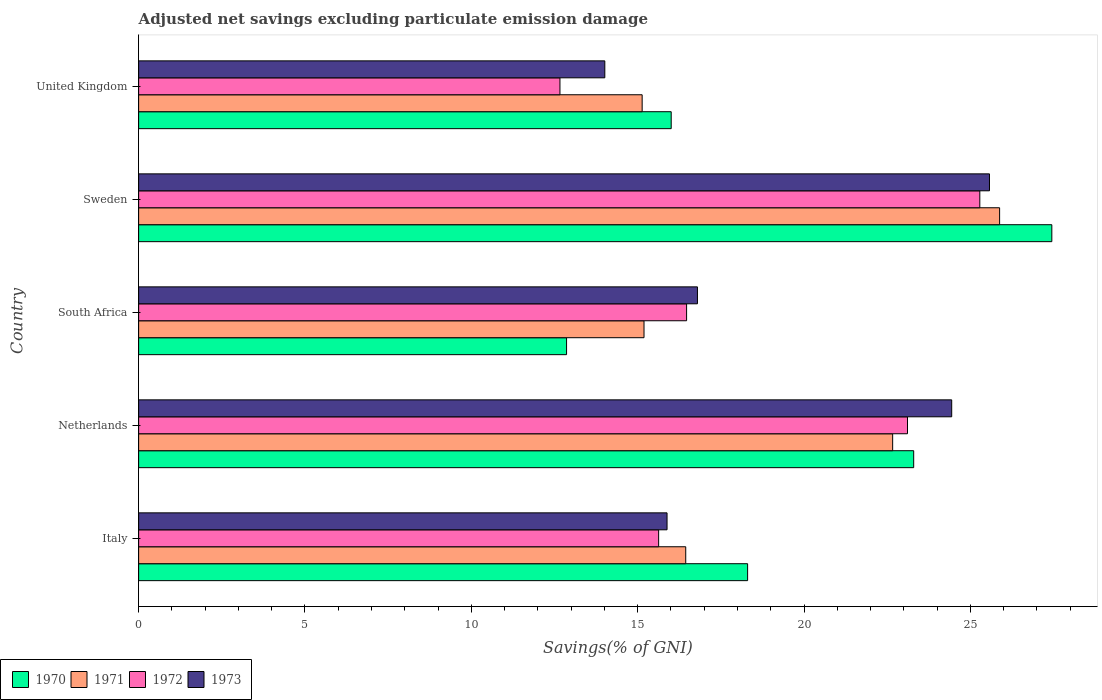How many groups of bars are there?
Give a very brief answer. 5. Are the number of bars per tick equal to the number of legend labels?
Ensure brevity in your answer.  Yes. Are the number of bars on each tick of the Y-axis equal?
Ensure brevity in your answer.  Yes. What is the label of the 3rd group of bars from the top?
Your answer should be compact. South Africa. What is the adjusted net savings in 1972 in South Africa?
Provide a short and direct response. 16.47. Across all countries, what is the maximum adjusted net savings in 1972?
Give a very brief answer. 25.28. Across all countries, what is the minimum adjusted net savings in 1972?
Give a very brief answer. 12.66. In which country was the adjusted net savings in 1972 maximum?
Offer a terse response. Sweden. What is the total adjusted net savings in 1973 in the graph?
Your answer should be compact. 96.7. What is the difference between the adjusted net savings in 1971 in South Africa and that in United Kingdom?
Your answer should be very brief. 0.06. What is the difference between the adjusted net savings in 1970 in Italy and the adjusted net savings in 1973 in South Africa?
Offer a terse response. 1.51. What is the average adjusted net savings in 1973 per country?
Offer a terse response. 19.34. What is the difference between the adjusted net savings in 1972 and adjusted net savings in 1973 in South Africa?
Offer a very short reply. -0.33. In how many countries, is the adjusted net savings in 1972 greater than 14 %?
Keep it short and to the point. 4. What is the ratio of the adjusted net savings in 1971 in Italy to that in South Africa?
Provide a short and direct response. 1.08. What is the difference between the highest and the second highest adjusted net savings in 1971?
Your response must be concise. 3.21. What is the difference between the highest and the lowest adjusted net savings in 1973?
Offer a very short reply. 11.56. What does the 3rd bar from the top in United Kingdom represents?
Provide a short and direct response. 1971. Is it the case that in every country, the sum of the adjusted net savings in 1973 and adjusted net savings in 1971 is greater than the adjusted net savings in 1972?
Provide a succinct answer. Yes. How many bars are there?
Offer a very short reply. 20. Are all the bars in the graph horizontal?
Provide a succinct answer. Yes. Are the values on the major ticks of X-axis written in scientific E-notation?
Give a very brief answer. No. Does the graph contain grids?
Keep it short and to the point. No. Where does the legend appear in the graph?
Make the answer very short. Bottom left. How are the legend labels stacked?
Provide a short and direct response. Horizontal. What is the title of the graph?
Make the answer very short. Adjusted net savings excluding particulate emission damage. What is the label or title of the X-axis?
Offer a terse response. Savings(% of GNI). What is the label or title of the Y-axis?
Offer a very short reply. Country. What is the Savings(% of GNI) of 1970 in Italy?
Make the answer very short. 18.3. What is the Savings(% of GNI) in 1971 in Italy?
Your answer should be compact. 16.44. What is the Savings(% of GNI) in 1972 in Italy?
Offer a very short reply. 15.63. What is the Savings(% of GNI) of 1973 in Italy?
Provide a succinct answer. 15.88. What is the Savings(% of GNI) of 1970 in Netherlands?
Provide a short and direct response. 23.3. What is the Savings(% of GNI) in 1971 in Netherlands?
Your response must be concise. 22.66. What is the Savings(% of GNI) in 1972 in Netherlands?
Your answer should be very brief. 23.11. What is the Savings(% of GNI) in 1973 in Netherlands?
Offer a very short reply. 24.44. What is the Savings(% of GNI) in 1970 in South Africa?
Make the answer very short. 12.86. What is the Savings(% of GNI) in 1971 in South Africa?
Make the answer very short. 15.19. What is the Savings(% of GNI) of 1972 in South Africa?
Your response must be concise. 16.47. What is the Savings(% of GNI) of 1973 in South Africa?
Your answer should be very brief. 16.8. What is the Savings(% of GNI) in 1970 in Sweden?
Your answer should be compact. 27.45. What is the Savings(% of GNI) of 1971 in Sweden?
Provide a short and direct response. 25.88. What is the Savings(% of GNI) in 1972 in Sweden?
Offer a very short reply. 25.28. What is the Savings(% of GNI) of 1973 in Sweden?
Ensure brevity in your answer.  25.57. What is the Savings(% of GNI) in 1970 in United Kingdom?
Your answer should be very brief. 16.01. What is the Savings(% of GNI) in 1971 in United Kingdom?
Provide a short and direct response. 15.13. What is the Savings(% of GNI) in 1972 in United Kingdom?
Your answer should be compact. 12.66. What is the Savings(% of GNI) of 1973 in United Kingdom?
Your answer should be very brief. 14.01. Across all countries, what is the maximum Savings(% of GNI) in 1970?
Make the answer very short. 27.45. Across all countries, what is the maximum Savings(% of GNI) in 1971?
Your response must be concise. 25.88. Across all countries, what is the maximum Savings(% of GNI) in 1972?
Provide a succinct answer. 25.28. Across all countries, what is the maximum Savings(% of GNI) of 1973?
Give a very brief answer. 25.57. Across all countries, what is the minimum Savings(% of GNI) in 1970?
Make the answer very short. 12.86. Across all countries, what is the minimum Savings(% of GNI) in 1971?
Offer a terse response. 15.13. Across all countries, what is the minimum Savings(% of GNI) in 1972?
Your answer should be compact. 12.66. Across all countries, what is the minimum Savings(% of GNI) in 1973?
Your response must be concise. 14.01. What is the total Savings(% of GNI) in 1970 in the graph?
Offer a very short reply. 97.92. What is the total Savings(% of GNI) of 1971 in the graph?
Ensure brevity in your answer.  95.31. What is the total Savings(% of GNI) in 1972 in the graph?
Give a very brief answer. 93.16. What is the total Savings(% of GNI) in 1973 in the graph?
Make the answer very short. 96.7. What is the difference between the Savings(% of GNI) of 1970 in Italy and that in Netherlands?
Offer a very short reply. -4.99. What is the difference between the Savings(% of GNI) in 1971 in Italy and that in Netherlands?
Give a very brief answer. -6.22. What is the difference between the Savings(% of GNI) of 1972 in Italy and that in Netherlands?
Give a very brief answer. -7.48. What is the difference between the Savings(% of GNI) in 1973 in Italy and that in Netherlands?
Provide a succinct answer. -8.56. What is the difference between the Savings(% of GNI) in 1970 in Italy and that in South Africa?
Provide a succinct answer. 5.44. What is the difference between the Savings(% of GNI) of 1971 in Italy and that in South Africa?
Your response must be concise. 1.25. What is the difference between the Savings(% of GNI) of 1972 in Italy and that in South Africa?
Ensure brevity in your answer.  -0.84. What is the difference between the Savings(% of GNI) in 1973 in Italy and that in South Africa?
Ensure brevity in your answer.  -0.91. What is the difference between the Savings(% of GNI) in 1970 in Italy and that in Sweden?
Offer a very short reply. -9.14. What is the difference between the Savings(% of GNI) in 1971 in Italy and that in Sweden?
Offer a very short reply. -9.43. What is the difference between the Savings(% of GNI) in 1972 in Italy and that in Sweden?
Your answer should be very brief. -9.65. What is the difference between the Savings(% of GNI) in 1973 in Italy and that in Sweden?
Provide a short and direct response. -9.69. What is the difference between the Savings(% of GNI) of 1970 in Italy and that in United Kingdom?
Your answer should be compact. 2.3. What is the difference between the Savings(% of GNI) in 1971 in Italy and that in United Kingdom?
Offer a very short reply. 1.31. What is the difference between the Savings(% of GNI) of 1972 in Italy and that in United Kingdom?
Provide a succinct answer. 2.97. What is the difference between the Savings(% of GNI) in 1973 in Italy and that in United Kingdom?
Your answer should be very brief. 1.87. What is the difference between the Savings(% of GNI) in 1970 in Netherlands and that in South Africa?
Give a very brief answer. 10.43. What is the difference between the Savings(% of GNI) in 1971 in Netherlands and that in South Africa?
Make the answer very short. 7.47. What is the difference between the Savings(% of GNI) of 1972 in Netherlands and that in South Africa?
Provide a short and direct response. 6.64. What is the difference between the Savings(% of GNI) of 1973 in Netherlands and that in South Africa?
Your response must be concise. 7.64. What is the difference between the Savings(% of GNI) of 1970 in Netherlands and that in Sweden?
Your response must be concise. -4.15. What is the difference between the Savings(% of GNI) in 1971 in Netherlands and that in Sweden?
Your answer should be compact. -3.21. What is the difference between the Savings(% of GNI) in 1972 in Netherlands and that in Sweden?
Keep it short and to the point. -2.17. What is the difference between the Savings(% of GNI) of 1973 in Netherlands and that in Sweden?
Your response must be concise. -1.14. What is the difference between the Savings(% of GNI) in 1970 in Netherlands and that in United Kingdom?
Your answer should be compact. 7.29. What is the difference between the Savings(% of GNI) in 1971 in Netherlands and that in United Kingdom?
Provide a short and direct response. 7.53. What is the difference between the Savings(% of GNI) of 1972 in Netherlands and that in United Kingdom?
Give a very brief answer. 10.45. What is the difference between the Savings(% of GNI) of 1973 in Netherlands and that in United Kingdom?
Provide a succinct answer. 10.43. What is the difference between the Savings(% of GNI) in 1970 in South Africa and that in Sweden?
Your answer should be compact. -14.59. What is the difference between the Savings(% of GNI) in 1971 in South Africa and that in Sweden?
Keep it short and to the point. -10.69. What is the difference between the Savings(% of GNI) of 1972 in South Africa and that in Sweden?
Give a very brief answer. -8.81. What is the difference between the Savings(% of GNI) of 1973 in South Africa and that in Sweden?
Give a very brief answer. -8.78. What is the difference between the Savings(% of GNI) in 1970 in South Africa and that in United Kingdom?
Offer a terse response. -3.15. What is the difference between the Savings(% of GNI) of 1971 in South Africa and that in United Kingdom?
Ensure brevity in your answer.  0.06. What is the difference between the Savings(% of GNI) in 1972 in South Africa and that in United Kingdom?
Keep it short and to the point. 3.81. What is the difference between the Savings(% of GNI) of 1973 in South Africa and that in United Kingdom?
Keep it short and to the point. 2.78. What is the difference between the Savings(% of GNI) of 1970 in Sweden and that in United Kingdom?
Your response must be concise. 11.44. What is the difference between the Savings(% of GNI) in 1971 in Sweden and that in United Kingdom?
Offer a very short reply. 10.74. What is the difference between the Savings(% of GNI) in 1972 in Sweden and that in United Kingdom?
Keep it short and to the point. 12.62. What is the difference between the Savings(% of GNI) in 1973 in Sweden and that in United Kingdom?
Keep it short and to the point. 11.56. What is the difference between the Savings(% of GNI) in 1970 in Italy and the Savings(% of GNI) in 1971 in Netherlands?
Your answer should be compact. -4.36. What is the difference between the Savings(% of GNI) in 1970 in Italy and the Savings(% of GNI) in 1972 in Netherlands?
Offer a terse response. -4.81. What is the difference between the Savings(% of GNI) of 1970 in Italy and the Savings(% of GNI) of 1973 in Netherlands?
Offer a very short reply. -6.13. What is the difference between the Savings(% of GNI) of 1971 in Italy and the Savings(% of GNI) of 1972 in Netherlands?
Give a very brief answer. -6.67. What is the difference between the Savings(% of GNI) in 1971 in Italy and the Savings(% of GNI) in 1973 in Netherlands?
Ensure brevity in your answer.  -7.99. What is the difference between the Savings(% of GNI) of 1972 in Italy and the Savings(% of GNI) of 1973 in Netherlands?
Ensure brevity in your answer.  -8.81. What is the difference between the Savings(% of GNI) in 1970 in Italy and the Savings(% of GNI) in 1971 in South Africa?
Your answer should be compact. 3.11. What is the difference between the Savings(% of GNI) in 1970 in Italy and the Savings(% of GNI) in 1972 in South Africa?
Offer a very short reply. 1.83. What is the difference between the Savings(% of GNI) of 1970 in Italy and the Savings(% of GNI) of 1973 in South Africa?
Your response must be concise. 1.51. What is the difference between the Savings(% of GNI) in 1971 in Italy and the Savings(% of GNI) in 1972 in South Africa?
Your answer should be compact. -0.03. What is the difference between the Savings(% of GNI) of 1971 in Italy and the Savings(% of GNI) of 1973 in South Africa?
Make the answer very short. -0.35. What is the difference between the Savings(% of GNI) in 1972 in Italy and the Savings(% of GNI) in 1973 in South Africa?
Make the answer very short. -1.17. What is the difference between the Savings(% of GNI) in 1970 in Italy and the Savings(% of GNI) in 1971 in Sweden?
Give a very brief answer. -7.57. What is the difference between the Savings(% of GNI) of 1970 in Italy and the Savings(% of GNI) of 1972 in Sweden?
Provide a succinct answer. -6.98. What is the difference between the Savings(% of GNI) of 1970 in Italy and the Savings(% of GNI) of 1973 in Sweden?
Offer a very short reply. -7.27. What is the difference between the Savings(% of GNI) in 1971 in Italy and the Savings(% of GNI) in 1972 in Sweden?
Your response must be concise. -8.84. What is the difference between the Savings(% of GNI) of 1971 in Italy and the Savings(% of GNI) of 1973 in Sweden?
Your answer should be compact. -9.13. What is the difference between the Savings(% of GNI) in 1972 in Italy and the Savings(% of GNI) in 1973 in Sweden?
Make the answer very short. -9.94. What is the difference between the Savings(% of GNI) in 1970 in Italy and the Savings(% of GNI) in 1971 in United Kingdom?
Ensure brevity in your answer.  3.17. What is the difference between the Savings(% of GNI) in 1970 in Italy and the Savings(% of GNI) in 1972 in United Kingdom?
Make the answer very short. 5.64. What is the difference between the Savings(% of GNI) of 1970 in Italy and the Savings(% of GNI) of 1973 in United Kingdom?
Make the answer very short. 4.29. What is the difference between the Savings(% of GNI) of 1971 in Italy and the Savings(% of GNI) of 1972 in United Kingdom?
Your answer should be very brief. 3.78. What is the difference between the Savings(% of GNI) in 1971 in Italy and the Savings(% of GNI) in 1973 in United Kingdom?
Make the answer very short. 2.43. What is the difference between the Savings(% of GNI) in 1972 in Italy and the Savings(% of GNI) in 1973 in United Kingdom?
Your answer should be very brief. 1.62. What is the difference between the Savings(% of GNI) of 1970 in Netherlands and the Savings(% of GNI) of 1971 in South Africa?
Offer a terse response. 8.11. What is the difference between the Savings(% of GNI) of 1970 in Netherlands and the Savings(% of GNI) of 1972 in South Africa?
Your answer should be compact. 6.83. What is the difference between the Savings(% of GNI) of 1970 in Netherlands and the Savings(% of GNI) of 1973 in South Africa?
Your response must be concise. 6.5. What is the difference between the Savings(% of GNI) of 1971 in Netherlands and the Savings(% of GNI) of 1972 in South Africa?
Keep it short and to the point. 6.19. What is the difference between the Savings(% of GNI) in 1971 in Netherlands and the Savings(% of GNI) in 1973 in South Africa?
Ensure brevity in your answer.  5.87. What is the difference between the Savings(% of GNI) in 1972 in Netherlands and the Savings(% of GNI) in 1973 in South Africa?
Your answer should be compact. 6.31. What is the difference between the Savings(% of GNI) of 1970 in Netherlands and the Savings(% of GNI) of 1971 in Sweden?
Ensure brevity in your answer.  -2.58. What is the difference between the Savings(% of GNI) in 1970 in Netherlands and the Savings(% of GNI) in 1972 in Sweden?
Your answer should be very brief. -1.99. What is the difference between the Savings(% of GNI) of 1970 in Netherlands and the Savings(% of GNI) of 1973 in Sweden?
Provide a succinct answer. -2.28. What is the difference between the Savings(% of GNI) of 1971 in Netherlands and the Savings(% of GNI) of 1972 in Sweden?
Ensure brevity in your answer.  -2.62. What is the difference between the Savings(% of GNI) of 1971 in Netherlands and the Savings(% of GNI) of 1973 in Sweden?
Provide a short and direct response. -2.91. What is the difference between the Savings(% of GNI) in 1972 in Netherlands and the Savings(% of GNI) in 1973 in Sweden?
Your answer should be compact. -2.46. What is the difference between the Savings(% of GNI) of 1970 in Netherlands and the Savings(% of GNI) of 1971 in United Kingdom?
Your answer should be very brief. 8.16. What is the difference between the Savings(% of GNI) in 1970 in Netherlands and the Savings(% of GNI) in 1972 in United Kingdom?
Your answer should be compact. 10.63. What is the difference between the Savings(% of GNI) in 1970 in Netherlands and the Savings(% of GNI) in 1973 in United Kingdom?
Give a very brief answer. 9.28. What is the difference between the Savings(% of GNI) of 1971 in Netherlands and the Savings(% of GNI) of 1972 in United Kingdom?
Your response must be concise. 10. What is the difference between the Savings(% of GNI) in 1971 in Netherlands and the Savings(% of GNI) in 1973 in United Kingdom?
Keep it short and to the point. 8.65. What is the difference between the Savings(% of GNI) in 1972 in Netherlands and the Savings(% of GNI) in 1973 in United Kingdom?
Your response must be concise. 9.1. What is the difference between the Savings(% of GNI) in 1970 in South Africa and the Savings(% of GNI) in 1971 in Sweden?
Provide a succinct answer. -13.02. What is the difference between the Savings(% of GNI) in 1970 in South Africa and the Savings(% of GNI) in 1972 in Sweden?
Your response must be concise. -12.42. What is the difference between the Savings(% of GNI) in 1970 in South Africa and the Savings(% of GNI) in 1973 in Sweden?
Provide a succinct answer. -12.71. What is the difference between the Savings(% of GNI) in 1971 in South Africa and the Savings(% of GNI) in 1972 in Sweden?
Keep it short and to the point. -10.09. What is the difference between the Savings(% of GNI) of 1971 in South Africa and the Savings(% of GNI) of 1973 in Sweden?
Offer a terse response. -10.38. What is the difference between the Savings(% of GNI) of 1972 in South Africa and the Savings(% of GNI) of 1973 in Sweden?
Make the answer very short. -9.1. What is the difference between the Savings(% of GNI) of 1970 in South Africa and the Savings(% of GNI) of 1971 in United Kingdom?
Your answer should be very brief. -2.27. What is the difference between the Savings(% of GNI) of 1970 in South Africa and the Savings(% of GNI) of 1972 in United Kingdom?
Provide a succinct answer. 0.2. What is the difference between the Savings(% of GNI) of 1970 in South Africa and the Savings(% of GNI) of 1973 in United Kingdom?
Your response must be concise. -1.15. What is the difference between the Savings(% of GNI) in 1971 in South Africa and the Savings(% of GNI) in 1972 in United Kingdom?
Offer a terse response. 2.53. What is the difference between the Savings(% of GNI) in 1971 in South Africa and the Savings(% of GNI) in 1973 in United Kingdom?
Ensure brevity in your answer.  1.18. What is the difference between the Savings(% of GNI) of 1972 in South Africa and the Savings(% of GNI) of 1973 in United Kingdom?
Ensure brevity in your answer.  2.46. What is the difference between the Savings(% of GNI) in 1970 in Sweden and the Savings(% of GNI) in 1971 in United Kingdom?
Keep it short and to the point. 12.31. What is the difference between the Savings(% of GNI) of 1970 in Sweden and the Savings(% of GNI) of 1972 in United Kingdom?
Offer a terse response. 14.78. What is the difference between the Savings(% of GNI) in 1970 in Sweden and the Savings(% of GNI) in 1973 in United Kingdom?
Your response must be concise. 13.44. What is the difference between the Savings(% of GNI) of 1971 in Sweden and the Savings(% of GNI) of 1972 in United Kingdom?
Ensure brevity in your answer.  13.21. What is the difference between the Savings(% of GNI) of 1971 in Sweden and the Savings(% of GNI) of 1973 in United Kingdom?
Give a very brief answer. 11.87. What is the difference between the Savings(% of GNI) in 1972 in Sweden and the Savings(% of GNI) in 1973 in United Kingdom?
Provide a succinct answer. 11.27. What is the average Savings(% of GNI) of 1970 per country?
Your response must be concise. 19.58. What is the average Savings(% of GNI) of 1971 per country?
Ensure brevity in your answer.  19.06. What is the average Savings(% of GNI) of 1972 per country?
Ensure brevity in your answer.  18.63. What is the average Savings(% of GNI) of 1973 per country?
Provide a succinct answer. 19.34. What is the difference between the Savings(% of GNI) in 1970 and Savings(% of GNI) in 1971 in Italy?
Your response must be concise. 1.86. What is the difference between the Savings(% of GNI) in 1970 and Savings(% of GNI) in 1972 in Italy?
Ensure brevity in your answer.  2.67. What is the difference between the Savings(% of GNI) of 1970 and Savings(% of GNI) of 1973 in Italy?
Your response must be concise. 2.42. What is the difference between the Savings(% of GNI) in 1971 and Savings(% of GNI) in 1972 in Italy?
Give a very brief answer. 0.81. What is the difference between the Savings(% of GNI) in 1971 and Savings(% of GNI) in 1973 in Italy?
Your answer should be very brief. 0.56. What is the difference between the Savings(% of GNI) in 1972 and Savings(% of GNI) in 1973 in Italy?
Make the answer very short. -0.25. What is the difference between the Savings(% of GNI) of 1970 and Savings(% of GNI) of 1971 in Netherlands?
Your response must be concise. 0.63. What is the difference between the Savings(% of GNI) of 1970 and Savings(% of GNI) of 1972 in Netherlands?
Make the answer very short. 0.19. What is the difference between the Savings(% of GNI) of 1970 and Savings(% of GNI) of 1973 in Netherlands?
Give a very brief answer. -1.14. What is the difference between the Savings(% of GNI) in 1971 and Savings(% of GNI) in 1972 in Netherlands?
Offer a terse response. -0.45. What is the difference between the Savings(% of GNI) in 1971 and Savings(% of GNI) in 1973 in Netherlands?
Your response must be concise. -1.77. What is the difference between the Savings(% of GNI) of 1972 and Savings(% of GNI) of 1973 in Netherlands?
Your answer should be compact. -1.33. What is the difference between the Savings(% of GNI) of 1970 and Savings(% of GNI) of 1971 in South Africa?
Provide a short and direct response. -2.33. What is the difference between the Savings(% of GNI) of 1970 and Savings(% of GNI) of 1972 in South Africa?
Give a very brief answer. -3.61. What is the difference between the Savings(% of GNI) of 1970 and Savings(% of GNI) of 1973 in South Africa?
Ensure brevity in your answer.  -3.93. What is the difference between the Savings(% of GNI) of 1971 and Savings(% of GNI) of 1972 in South Africa?
Ensure brevity in your answer.  -1.28. What is the difference between the Savings(% of GNI) in 1971 and Savings(% of GNI) in 1973 in South Africa?
Offer a very short reply. -1.61. What is the difference between the Savings(% of GNI) of 1972 and Savings(% of GNI) of 1973 in South Africa?
Provide a short and direct response. -0.33. What is the difference between the Savings(% of GNI) of 1970 and Savings(% of GNI) of 1971 in Sweden?
Offer a terse response. 1.57. What is the difference between the Savings(% of GNI) of 1970 and Savings(% of GNI) of 1972 in Sweden?
Offer a very short reply. 2.16. What is the difference between the Savings(% of GNI) of 1970 and Savings(% of GNI) of 1973 in Sweden?
Your answer should be very brief. 1.87. What is the difference between the Savings(% of GNI) in 1971 and Savings(% of GNI) in 1972 in Sweden?
Provide a succinct answer. 0.59. What is the difference between the Savings(% of GNI) in 1971 and Savings(% of GNI) in 1973 in Sweden?
Give a very brief answer. 0.3. What is the difference between the Savings(% of GNI) of 1972 and Savings(% of GNI) of 1973 in Sweden?
Make the answer very short. -0.29. What is the difference between the Savings(% of GNI) of 1970 and Savings(% of GNI) of 1971 in United Kingdom?
Ensure brevity in your answer.  0.87. What is the difference between the Savings(% of GNI) in 1970 and Savings(% of GNI) in 1972 in United Kingdom?
Keep it short and to the point. 3.34. What is the difference between the Savings(% of GNI) of 1970 and Savings(% of GNI) of 1973 in United Kingdom?
Provide a succinct answer. 2. What is the difference between the Savings(% of GNI) in 1971 and Savings(% of GNI) in 1972 in United Kingdom?
Provide a succinct answer. 2.47. What is the difference between the Savings(% of GNI) of 1971 and Savings(% of GNI) of 1973 in United Kingdom?
Give a very brief answer. 1.12. What is the difference between the Savings(% of GNI) in 1972 and Savings(% of GNI) in 1973 in United Kingdom?
Give a very brief answer. -1.35. What is the ratio of the Savings(% of GNI) of 1970 in Italy to that in Netherlands?
Make the answer very short. 0.79. What is the ratio of the Savings(% of GNI) of 1971 in Italy to that in Netherlands?
Your answer should be compact. 0.73. What is the ratio of the Savings(% of GNI) of 1972 in Italy to that in Netherlands?
Your response must be concise. 0.68. What is the ratio of the Savings(% of GNI) in 1973 in Italy to that in Netherlands?
Offer a very short reply. 0.65. What is the ratio of the Savings(% of GNI) of 1970 in Italy to that in South Africa?
Your answer should be compact. 1.42. What is the ratio of the Savings(% of GNI) of 1971 in Italy to that in South Africa?
Provide a succinct answer. 1.08. What is the ratio of the Savings(% of GNI) of 1972 in Italy to that in South Africa?
Make the answer very short. 0.95. What is the ratio of the Savings(% of GNI) in 1973 in Italy to that in South Africa?
Your answer should be very brief. 0.95. What is the ratio of the Savings(% of GNI) in 1970 in Italy to that in Sweden?
Give a very brief answer. 0.67. What is the ratio of the Savings(% of GNI) in 1971 in Italy to that in Sweden?
Provide a succinct answer. 0.64. What is the ratio of the Savings(% of GNI) in 1972 in Italy to that in Sweden?
Keep it short and to the point. 0.62. What is the ratio of the Savings(% of GNI) of 1973 in Italy to that in Sweden?
Your answer should be very brief. 0.62. What is the ratio of the Savings(% of GNI) in 1970 in Italy to that in United Kingdom?
Make the answer very short. 1.14. What is the ratio of the Savings(% of GNI) of 1971 in Italy to that in United Kingdom?
Your response must be concise. 1.09. What is the ratio of the Savings(% of GNI) in 1972 in Italy to that in United Kingdom?
Offer a terse response. 1.23. What is the ratio of the Savings(% of GNI) in 1973 in Italy to that in United Kingdom?
Give a very brief answer. 1.13. What is the ratio of the Savings(% of GNI) in 1970 in Netherlands to that in South Africa?
Offer a terse response. 1.81. What is the ratio of the Savings(% of GNI) of 1971 in Netherlands to that in South Africa?
Keep it short and to the point. 1.49. What is the ratio of the Savings(% of GNI) of 1972 in Netherlands to that in South Africa?
Offer a very short reply. 1.4. What is the ratio of the Savings(% of GNI) in 1973 in Netherlands to that in South Africa?
Provide a short and direct response. 1.46. What is the ratio of the Savings(% of GNI) of 1970 in Netherlands to that in Sweden?
Your answer should be compact. 0.85. What is the ratio of the Savings(% of GNI) in 1971 in Netherlands to that in Sweden?
Ensure brevity in your answer.  0.88. What is the ratio of the Savings(% of GNI) in 1972 in Netherlands to that in Sweden?
Your answer should be very brief. 0.91. What is the ratio of the Savings(% of GNI) of 1973 in Netherlands to that in Sweden?
Your answer should be compact. 0.96. What is the ratio of the Savings(% of GNI) of 1970 in Netherlands to that in United Kingdom?
Ensure brevity in your answer.  1.46. What is the ratio of the Savings(% of GNI) of 1971 in Netherlands to that in United Kingdom?
Your response must be concise. 1.5. What is the ratio of the Savings(% of GNI) of 1972 in Netherlands to that in United Kingdom?
Your answer should be very brief. 1.82. What is the ratio of the Savings(% of GNI) of 1973 in Netherlands to that in United Kingdom?
Provide a short and direct response. 1.74. What is the ratio of the Savings(% of GNI) of 1970 in South Africa to that in Sweden?
Provide a short and direct response. 0.47. What is the ratio of the Savings(% of GNI) of 1971 in South Africa to that in Sweden?
Provide a short and direct response. 0.59. What is the ratio of the Savings(% of GNI) of 1972 in South Africa to that in Sweden?
Provide a succinct answer. 0.65. What is the ratio of the Savings(% of GNI) in 1973 in South Africa to that in Sweden?
Make the answer very short. 0.66. What is the ratio of the Savings(% of GNI) of 1970 in South Africa to that in United Kingdom?
Your answer should be compact. 0.8. What is the ratio of the Savings(% of GNI) in 1972 in South Africa to that in United Kingdom?
Provide a short and direct response. 1.3. What is the ratio of the Savings(% of GNI) of 1973 in South Africa to that in United Kingdom?
Offer a very short reply. 1.2. What is the ratio of the Savings(% of GNI) in 1970 in Sweden to that in United Kingdom?
Provide a succinct answer. 1.71. What is the ratio of the Savings(% of GNI) in 1971 in Sweden to that in United Kingdom?
Your response must be concise. 1.71. What is the ratio of the Savings(% of GNI) in 1972 in Sweden to that in United Kingdom?
Keep it short and to the point. 2. What is the ratio of the Savings(% of GNI) in 1973 in Sweden to that in United Kingdom?
Keep it short and to the point. 1.83. What is the difference between the highest and the second highest Savings(% of GNI) of 1970?
Keep it short and to the point. 4.15. What is the difference between the highest and the second highest Savings(% of GNI) of 1971?
Make the answer very short. 3.21. What is the difference between the highest and the second highest Savings(% of GNI) of 1972?
Keep it short and to the point. 2.17. What is the difference between the highest and the second highest Savings(% of GNI) of 1973?
Your answer should be very brief. 1.14. What is the difference between the highest and the lowest Savings(% of GNI) in 1970?
Your answer should be compact. 14.59. What is the difference between the highest and the lowest Savings(% of GNI) in 1971?
Make the answer very short. 10.74. What is the difference between the highest and the lowest Savings(% of GNI) of 1972?
Ensure brevity in your answer.  12.62. What is the difference between the highest and the lowest Savings(% of GNI) of 1973?
Provide a succinct answer. 11.56. 